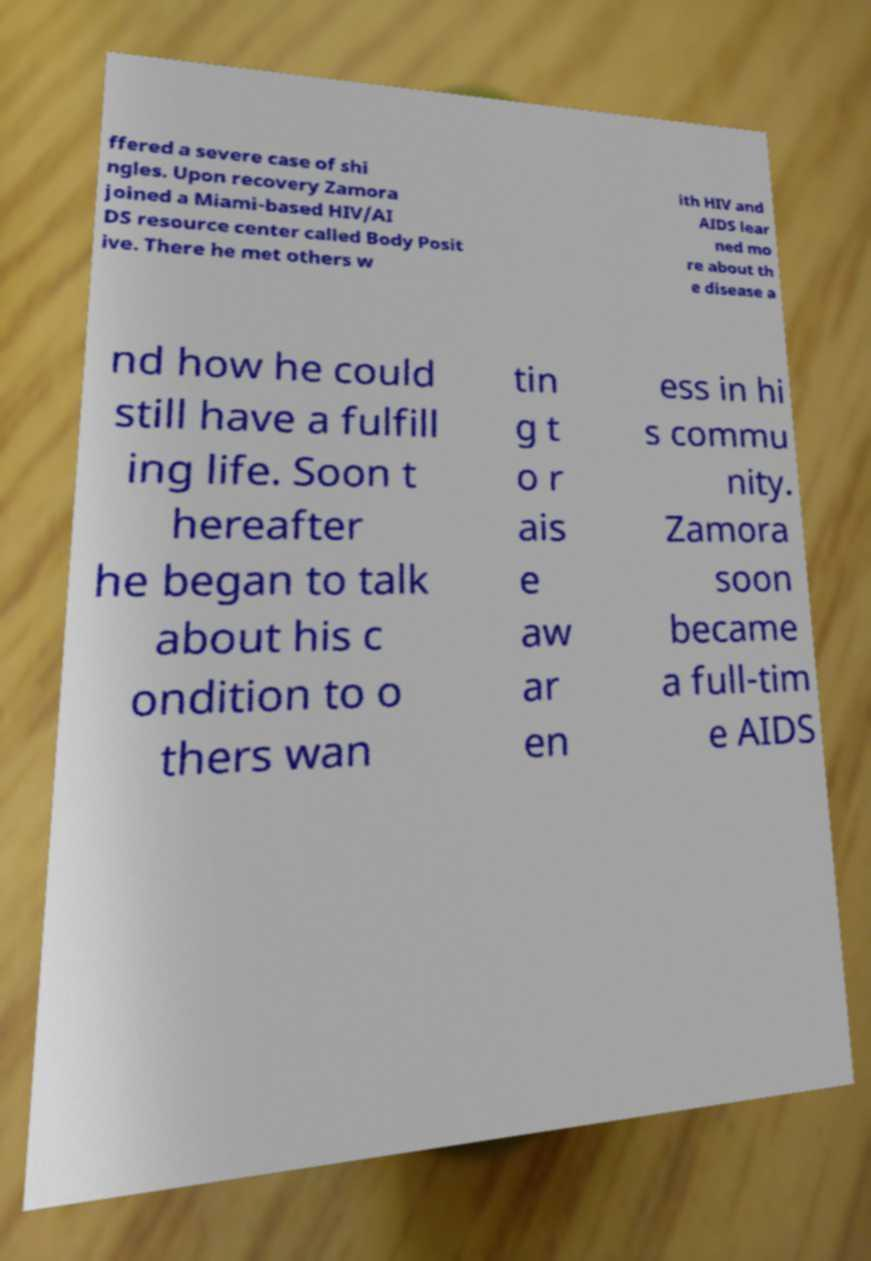What messages or text are displayed in this image? I need them in a readable, typed format. ffered a severe case of shi ngles. Upon recovery Zamora joined a Miami-based HIV/AI DS resource center called Body Posit ive. There he met others w ith HIV and AIDS lear ned mo re about th e disease a nd how he could still have a fulfill ing life. Soon t hereafter he began to talk about his c ondition to o thers wan tin g t o r ais e aw ar en ess in hi s commu nity. Zamora soon became a full-tim e AIDS 